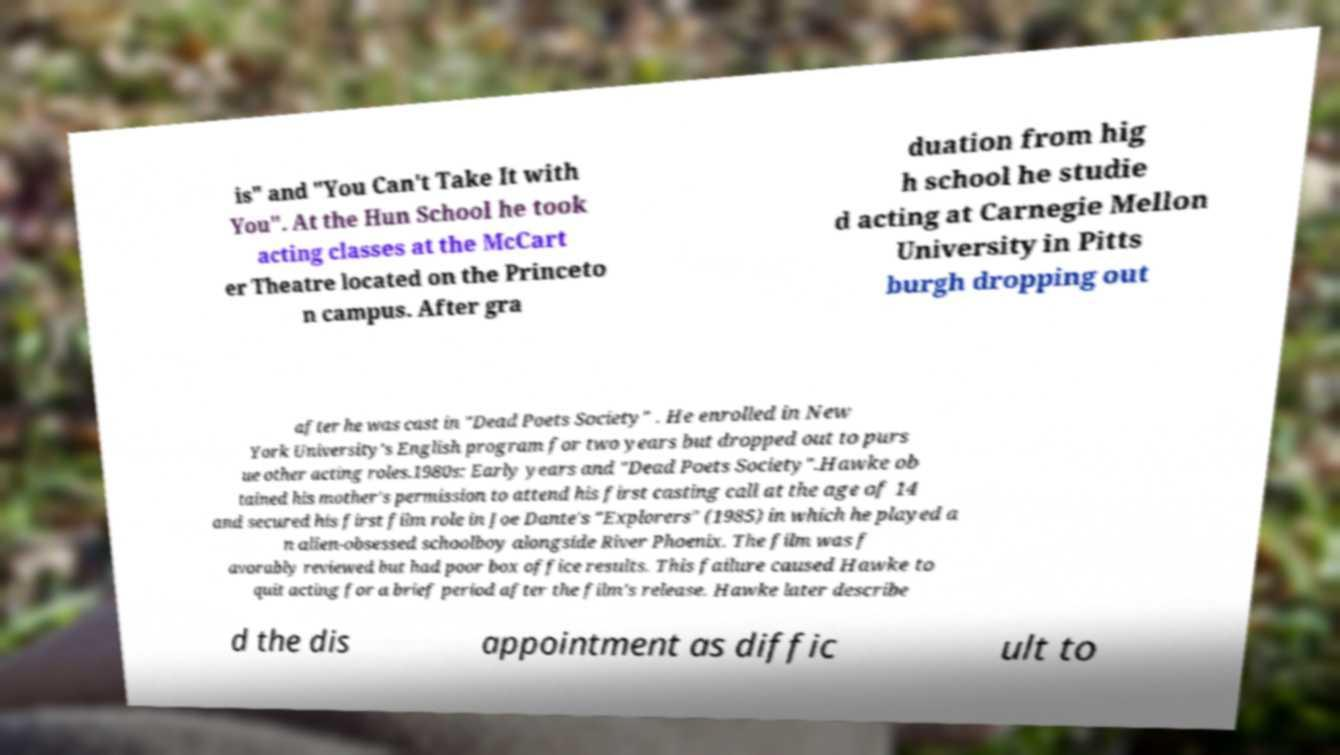What messages or text are displayed in this image? I need them in a readable, typed format. is" and "You Can't Take It with You". At the Hun School he took acting classes at the McCart er Theatre located on the Princeto n campus. After gra duation from hig h school he studie d acting at Carnegie Mellon University in Pitts burgh dropping out after he was cast in "Dead Poets Society" . He enrolled in New York University's English program for two years but dropped out to purs ue other acting roles.1980s: Early years and "Dead Poets Society".Hawke ob tained his mother's permission to attend his first casting call at the age of 14 and secured his first film role in Joe Dante's "Explorers" (1985) in which he played a n alien-obsessed schoolboy alongside River Phoenix. The film was f avorably reviewed but had poor box office results. This failure caused Hawke to quit acting for a brief period after the film's release. Hawke later describe d the dis appointment as diffic ult to 